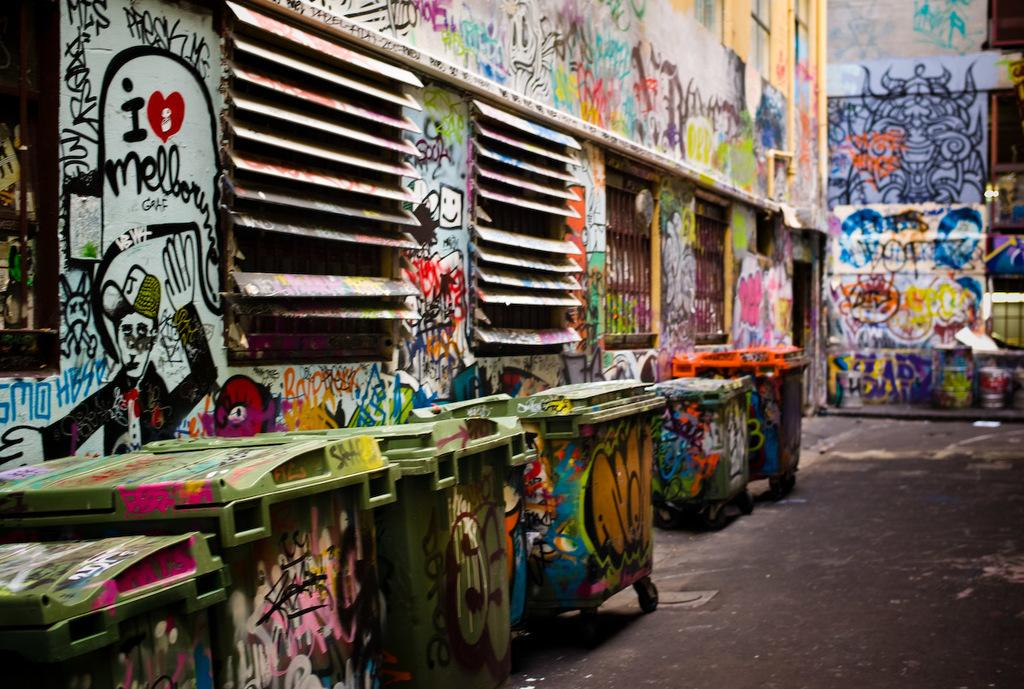<image>
Provide a brief description of the given image. A building and trash bins with various graffiti including a graffiti of a man in a suit with a cap with a character "J". 